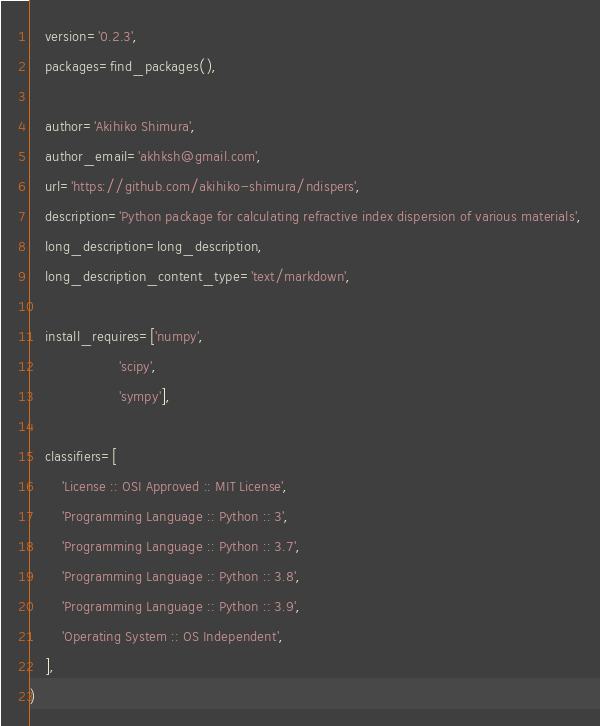Convert code to text. <code><loc_0><loc_0><loc_500><loc_500><_Python_>    version='0.2.3',
    packages=find_packages(),

    author='Akihiko Shimura',
    author_email='akhksh@gmail.com',
    url='https://github.com/akihiko-shimura/ndispers',
    description='Python package for calculating refractive index dispersion of various materials',
    long_description=long_description,
    long_description_content_type='text/markdown',

    install_requires=['numpy', 
                      'scipy', 
                      'sympy'],

    classifiers=[
        'License :: OSI Approved :: MIT License',
        'Programming Language :: Python :: 3',
        'Programming Language :: Python :: 3.7',
        'Programming Language :: Python :: 3.8',
        'Programming Language :: Python :: 3.9',
        'Operating System :: OS Independent',
    ],
)
</code> 